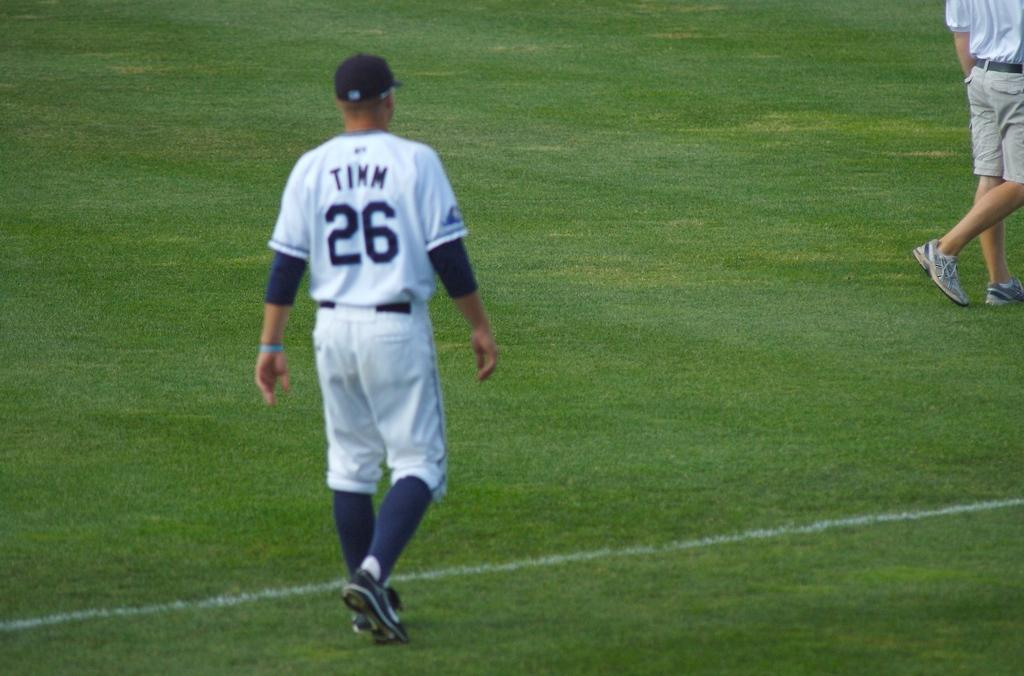<image>
Provide a brief description of the given image. The baseball player who wears the number 26 uniform is named TIMM. 